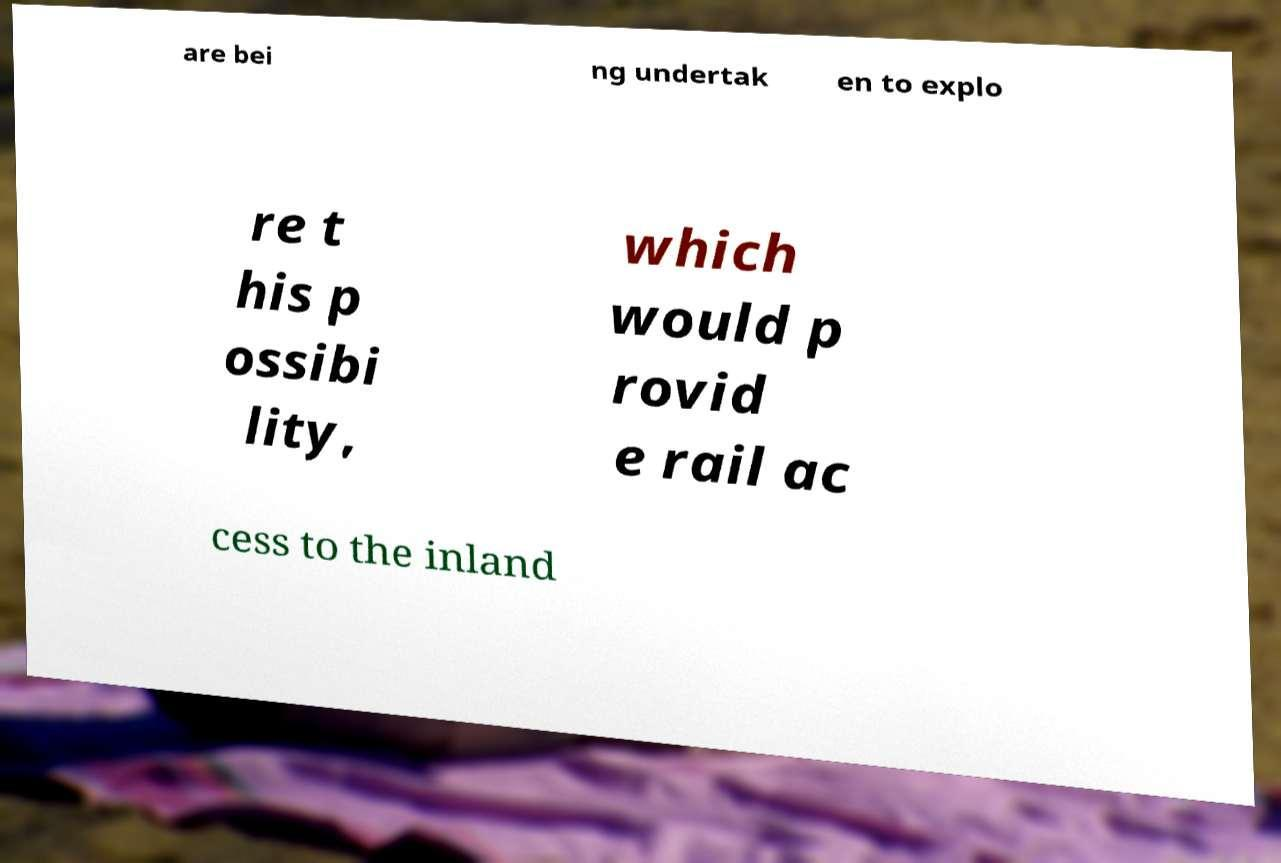Could you extract and type out the text from this image? are bei ng undertak en to explo re t his p ossibi lity, which would p rovid e rail ac cess to the inland 